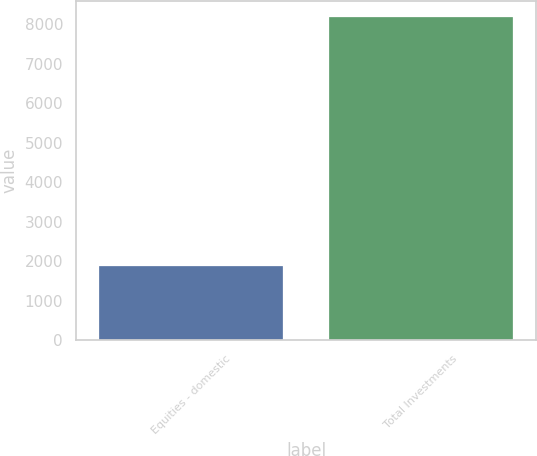<chart> <loc_0><loc_0><loc_500><loc_500><bar_chart><fcel>Equities - domestic<fcel>Total Investments<nl><fcel>1889<fcel>8185<nl></chart> 